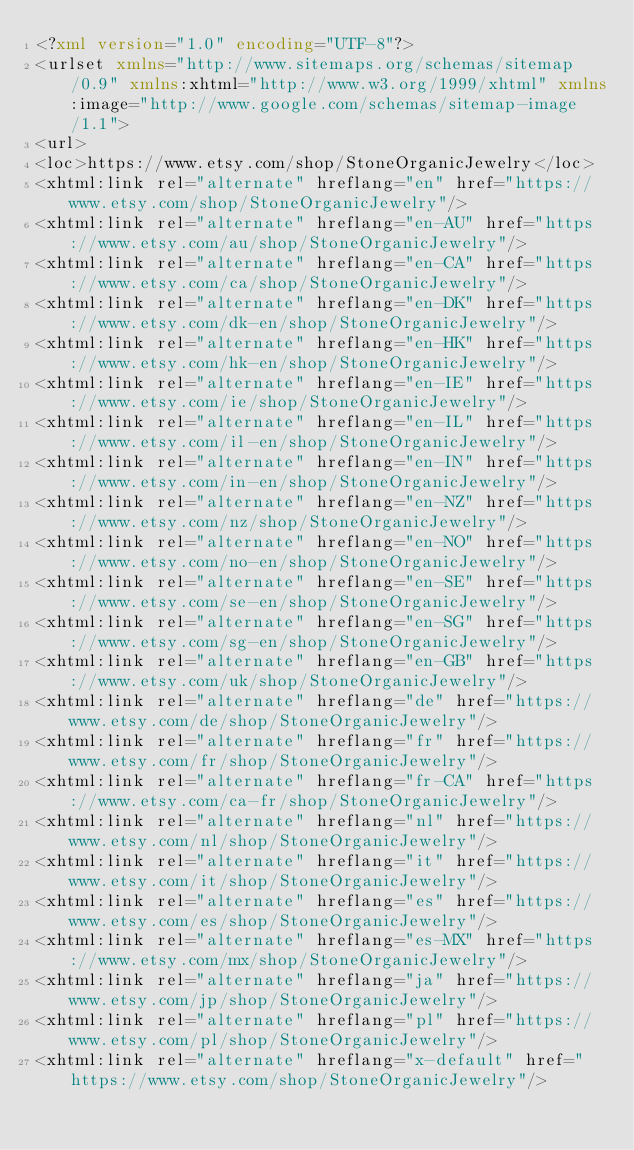<code> <loc_0><loc_0><loc_500><loc_500><_XML_><?xml version="1.0" encoding="UTF-8"?>
<urlset xmlns="http://www.sitemaps.org/schemas/sitemap/0.9" xmlns:xhtml="http://www.w3.org/1999/xhtml" xmlns:image="http://www.google.com/schemas/sitemap-image/1.1">
<url>
<loc>https://www.etsy.com/shop/StoneOrganicJewelry</loc>
<xhtml:link rel="alternate" hreflang="en" href="https://www.etsy.com/shop/StoneOrganicJewelry"/>
<xhtml:link rel="alternate" hreflang="en-AU" href="https://www.etsy.com/au/shop/StoneOrganicJewelry"/>
<xhtml:link rel="alternate" hreflang="en-CA" href="https://www.etsy.com/ca/shop/StoneOrganicJewelry"/>
<xhtml:link rel="alternate" hreflang="en-DK" href="https://www.etsy.com/dk-en/shop/StoneOrganicJewelry"/>
<xhtml:link rel="alternate" hreflang="en-HK" href="https://www.etsy.com/hk-en/shop/StoneOrganicJewelry"/>
<xhtml:link rel="alternate" hreflang="en-IE" href="https://www.etsy.com/ie/shop/StoneOrganicJewelry"/>
<xhtml:link rel="alternate" hreflang="en-IL" href="https://www.etsy.com/il-en/shop/StoneOrganicJewelry"/>
<xhtml:link rel="alternate" hreflang="en-IN" href="https://www.etsy.com/in-en/shop/StoneOrganicJewelry"/>
<xhtml:link rel="alternate" hreflang="en-NZ" href="https://www.etsy.com/nz/shop/StoneOrganicJewelry"/>
<xhtml:link rel="alternate" hreflang="en-NO" href="https://www.etsy.com/no-en/shop/StoneOrganicJewelry"/>
<xhtml:link rel="alternate" hreflang="en-SE" href="https://www.etsy.com/se-en/shop/StoneOrganicJewelry"/>
<xhtml:link rel="alternate" hreflang="en-SG" href="https://www.etsy.com/sg-en/shop/StoneOrganicJewelry"/>
<xhtml:link rel="alternate" hreflang="en-GB" href="https://www.etsy.com/uk/shop/StoneOrganicJewelry"/>
<xhtml:link rel="alternate" hreflang="de" href="https://www.etsy.com/de/shop/StoneOrganicJewelry"/>
<xhtml:link rel="alternate" hreflang="fr" href="https://www.etsy.com/fr/shop/StoneOrganicJewelry"/>
<xhtml:link rel="alternate" hreflang="fr-CA" href="https://www.etsy.com/ca-fr/shop/StoneOrganicJewelry"/>
<xhtml:link rel="alternate" hreflang="nl" href="https://www.etsy.com/nl/shop/StoneOrganicJewelry"/>
<xhtml:link rel="alternate" hreflang="it" href="https://www.etsy.com/it/shop/StoneOrganicJewelry"/>
<xhtml:link rel="alternate" hreflang="es" href="https://www.etsy.com/es/shop/StoneOrganicJewelry"/>
<xhtml:link rel="alternate" hreflang="es-MX" href="https://www.etsy.com/mx/shop/StoneOrganicJewelry"/>
<xhtml:link rel="alternate" hreflang="ja" href="https://www.etsy.com/jp/shop/StoneOrganicJewelry"/>
<xhtml:link rel="alternate" hreflang="pl" href="https://www.etsy.com/pl/shop/StoneOrganicJewelry"/>
<xhtml:link rel="alternate" hreflang="x-default" href="https://www.etsy.com/shop/StoneOrganicJewelry"/></code> 